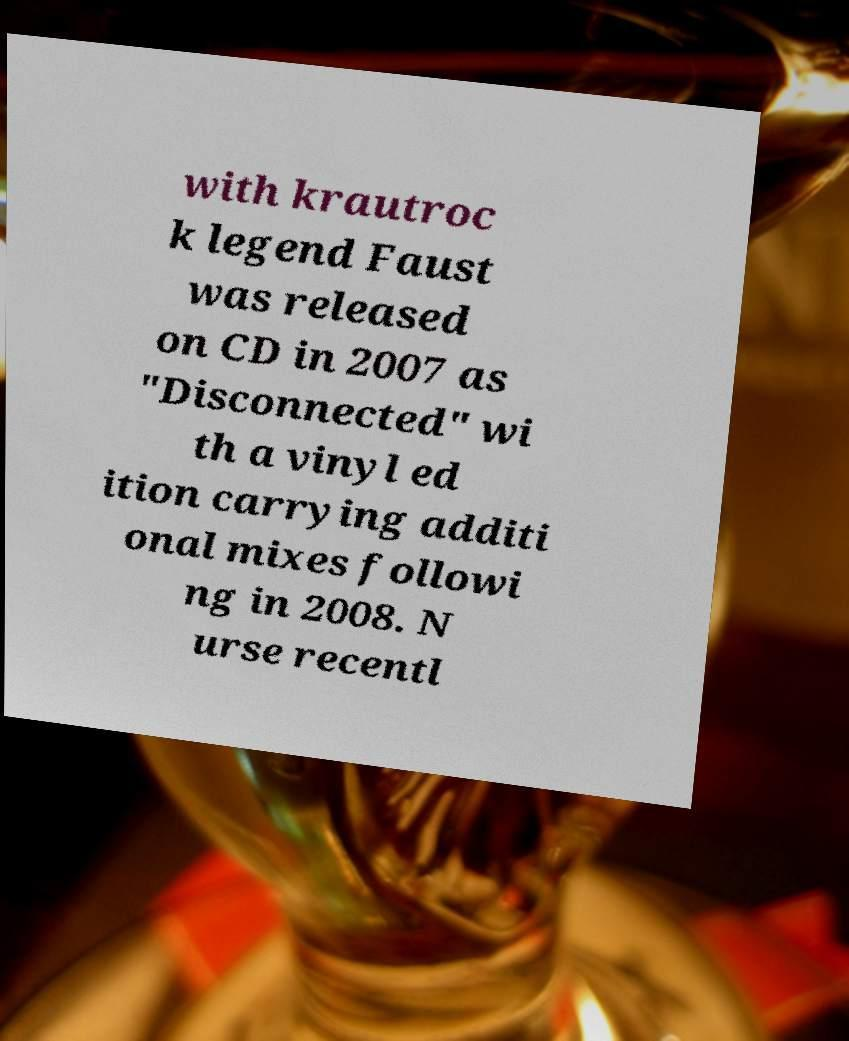Could you extract and type out the text from this image? with krautroc k legend Faust was released on CD in 2007 as "Disconnected" wi th a vinyl ed ition carrying additi onal mixes followi ng in 2008. N urse recentl 